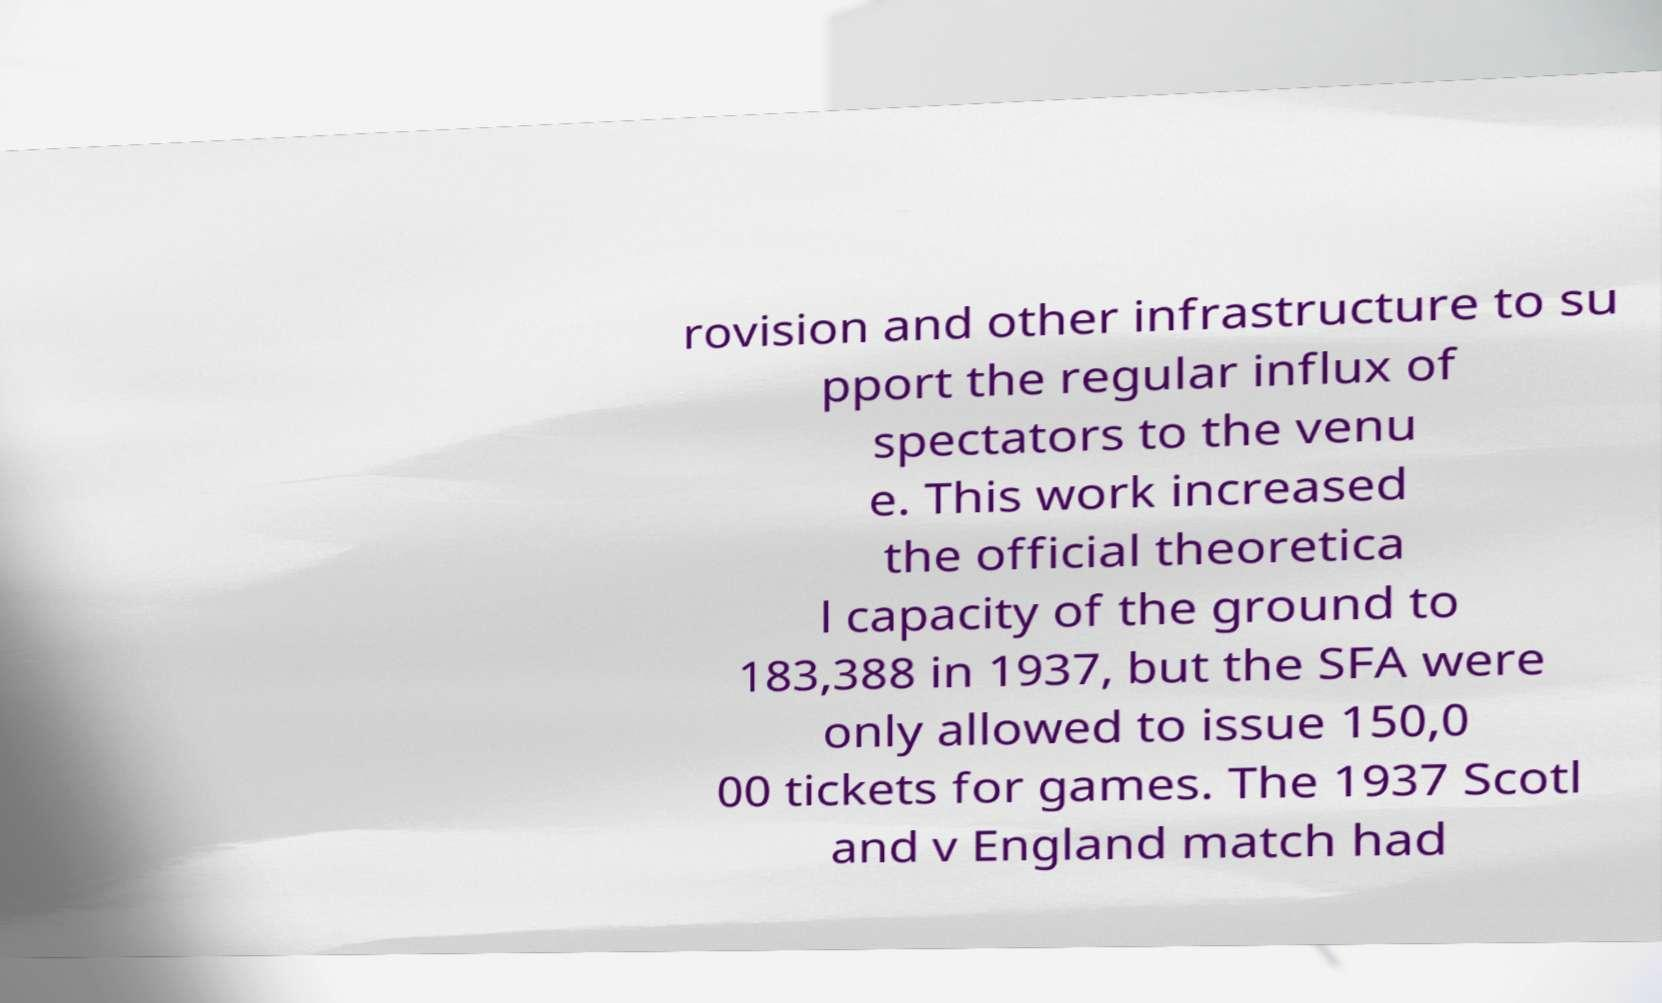Can you read and provide the text displayed in the image?This photo seems to have some interesting text. Can you extract and type it out for me? rovision and other infrastructure to su pport the regular influx of spectators to the venu e. This work increased the official theoretica l capacity of the ground to 183,388 in 1937, but the SFA were only allowed to issue 150,0 00 tickets for games. The 1937 Scotl and v England match had 